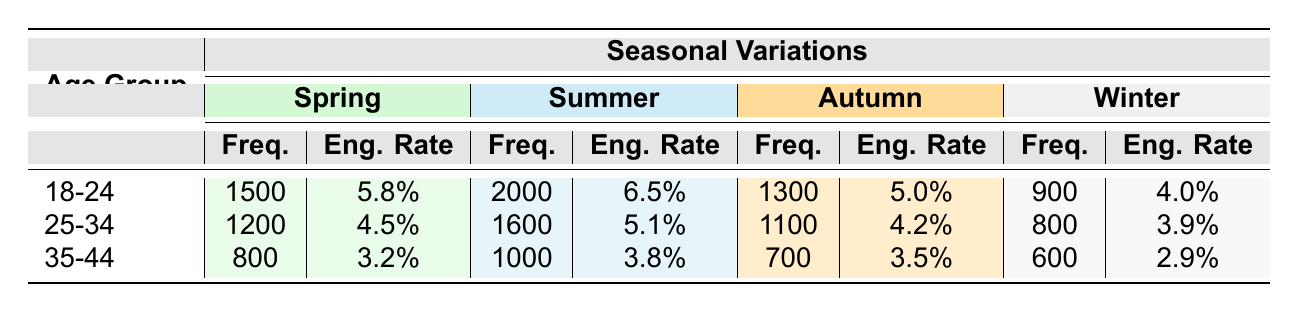What is the posting frequency of the 18-24 age group in Summer? The table shows that the posting frequency for the 18-24 age group in Summer is clearly listed under the Summer column. It indicates a frequency of 2000.
Answer: 2000 Which age group has the highest engagement rate in Spring? By comparing the Engagement Rates for each age group in Spring, the ages 18-24 have the highest engagement rate listed as 5.8%.
Answer: Ages 18-24 What is the total frequency of selfie posts by the 25-34 age group across all seasons? To find the total frequency for the 25-34 age group, we add their frequencies for each season: 1200 (Spring) + 1600 (Summer) + 1100 (Autumn) + 800 (Winter) = 3700.
Answer: 3700 Is the engagement rate for the 35-44 age group higher in Autumn than in Winter? The engagement rate for the 35-44 age group in Autumn is 3.5%, while in Winter it is lower at 2.9%. Since 3.5% is greater than 2.9%, the statement is true.
Answer: Yes What season showed the largest difference in posting frequency for the 18-24 age group between Summer and Winter? The posting frequencies for the 18-24 age group are 2000 (Summer) and 900 (Winter). The difference is calculated by subtracting Winter from Summer: 2000 - 900 = 1100, indicating the largest difference occurs in Summer compared to Winter.
Answer: 1100 